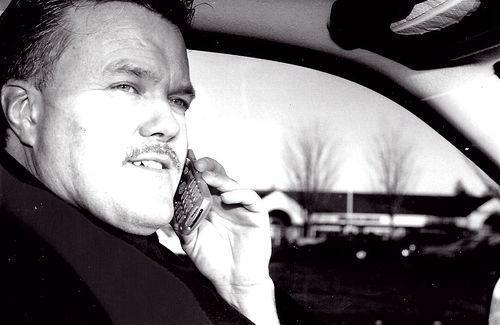How many people are in the photo?
Give a very brief answer. 1. How many light on the front of the train are lit?
Give a very brief answer. 0. 